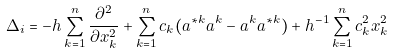Convert formula to latex. <formula><loc_0><loc_0><loc_500><loc_500>\Delta _ { i } = - h \sum _ { k = 1 } ^ { n } \frac { \partial ^ { 2 } } { \partial x _ { k } ^ { 2 } } + \sum _ { k = 1 } ^ { n } c _ { k } ( a ^ { * k } a ^ { k } - a ^ { k } a ^ { * k } ) + h ^ { - 1 } \sum _ { k = 1 } ^ { n } c ^ { 2 } _ { k } x ^ { 2 } _ { k }</formula> 